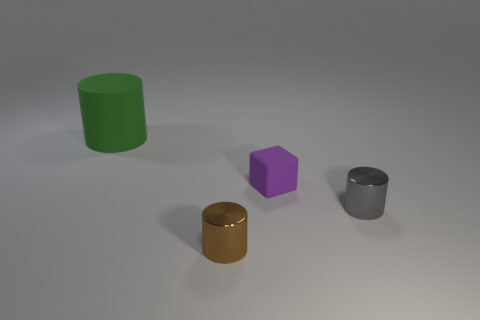Could the arrangement of the objects have any symbolic meaning? The arrangement of objects does not immediately suggest a specific symbolic meaning. They are spaced apart without a discernible pattern. If there is symbolic meaning, it is not readily apparent from the image alone and could require additional context. 